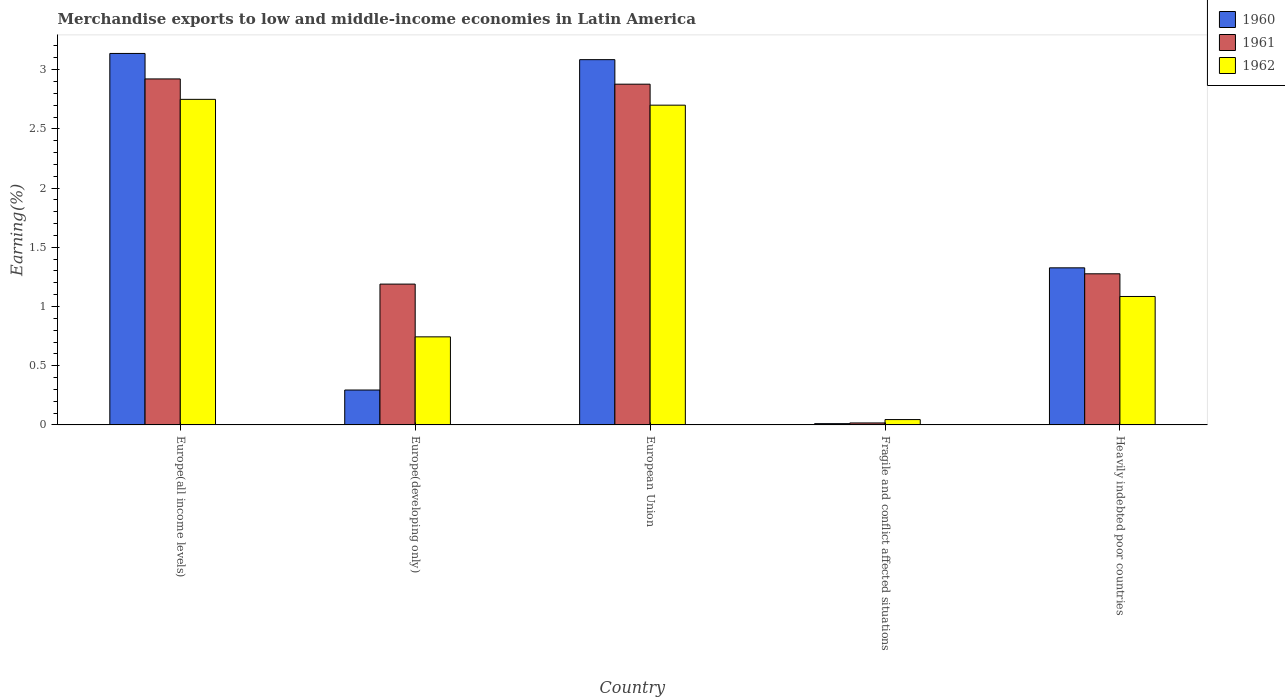How many different coloured bars are there?
Your answer should be compact. 3. What is the label of the 2nd group of bars from the left?
Provide a short and direct response. Europe(developing only). In how many cases, is the number of bars for a given country not equal to the number of legend labels?
Your answer should be very brief. 0. What is the percentage of amount earned from merchandise exports in 1961 in Europe(developing only)?
Keep it short and to the point. 1.19. Across all countries, what is the maximum percentage of amount earned from merchandise exports in 1961?
Ensure brevity in your answer.  2.92. Across all countries, what is the minimum percentage of amount earned from merchandise exports in 1961?
Provide a short and direct response. 0.02. In which country was the percentage of amount earned from merchandise exports in 1960 maximum?
Offer a terse response. Europe(all income levels). In which country was the percentage of amount earned from merchandise exports in 1962 minimum?
Offer a terse response. Fragile and conflict affected situations. What is the total percentage of amount earned from merchandise exports in 1960 in the graph?
Offer a terse response. 7.85. What is the difference between the percentage of amount earned from merchandise exports in 1960 in Europe(developing only) and that in Fragile and conflict affected situations?
Keep it short and to the point. 0.28. What is the difference between the percentage of amount earned from merchandise exports in 1960 in Fragile and conflict affected situations and the percentage of amount earned from merchandise exports in 1962 in Heavily indebted poor countries?
Your answer should be very brief. -1.07. What is the average percentage of amount earned from merchandise exports in 1960 per country?
Give a very brief answer. 1.57. What is the difference between the percentage of amount earned from merchandise exports of/in 1961 and percentage of amount earned from merchandise exports of/in 1960 in Heavily indebted poor countries?
Provide a succinct answer. -0.05. What is the ratio of the percentage of amount earned from merchandise exports in 1961 in Europe(developing only) to that in European Union?
Keep it short and to the point. 0.41. Is the difference between the percentage of amount earned from merchandise exports in 1961 in European Union and Fragile and conflict affected situations greater than the difference between the percentage of amount earned from merchandise exports in 1960 in European Union and Fragile and conflict affected situations?
Offer a terse response. No. What is the difference between the highest and the second highest percentage of amount earned from merchandise exports in 1960?
Provide a short and direct response. 1.76. What is the difference between the highest and the lowest percentage of amount earned from merchandise exports in 1961?
Your answer should be very brief. 2.91. In how many countries, is the percentage of amount earned from merchandise exports in 1962 greater than the average percentage of amount earned from merchandise exports in 1962 taken over all countries?
Ensure brevity in your answer.  2. Is it the case that in every country, the sum of the percentage of amount earned from merchandise exports in 1961 and percentage of amount earned from merchandise exports in 1962 is greater than the percentage of amount earned from merchandise exports in 1960?
Your response must be concise. Yes. Are all the bars in the graph horizontal?
Provide a short and direct response. No. How many countries are there in the graph?
Offer a terse response. 5. Does the graph contain any zero values?
Your answer should be very brief. No. Does the graph contain grids?
Provide a succinct answer. No. How many legend labels are there?
Provide a short and direct response. 3. How are the legend labels stacked?
Provide a short and direct response. Vertical. What is the title of the graph?
Provide a short and direct response. Merchandise exports to low and middle-income economies in Latin America. What is the label or title of the Y-axis?
Make the answer very short. Earning(%). What is the Earning(%) of 1960 in Europe(all income levels)?
Provide a short and direct response. 3.14. What is the Earning(%) of 1961 in Europe(all income levels)?
Offer a terse response. 2.92. What is the Earning(%) in 1962 in Europe(all income levels)?
Your answer should be compact. 2.75. What is the Earning(%) in 1960 in Europe(developing only)?
Provide a succinct answer. 0.29. What is the Earning(%) of 1961 in Europe(developing only)?
Offer a terse response. 1.19. What is the Earning(%) of 1962 in Europe(developing only)?
Your answer should be compact. 0.74. What is the Earning(%) of 1960 in European Union?
Keep it short and to the point. 3.08. What is the Earning(%) in 1961 in European Union?
Make the answer very short. 2.88. What is the Earning(%) in 1962 in European Union?
Give a very brief answer. 2.7. What is the Earning(%) of 1960 in Fragile and conflict affected situations?
Offer a terse response. 0.01. What is the Earning(%) in 1961 in Fragile and conflict affected situations?
Your answer should be very brief. 0.02. What is the Earning(%) in 1962 in Fragile and conflict affected situations?
Offer a very short reply. 0.05. What is the Earning(%) of 1960 in Heavily indebted poor countries?
Offer a very short reply. 1.33. What is the Earning(%) in 1961 in Heavily indebted poor countries?
Give a very brief answer. 1.28. What is the Earning(%) of 1962 in Heavily indebted poor countries?
Offer a terse response. 1.08. Across all countries, what is the maximum Earning(%) of 1960?
Your answer should be compact. 3.14. Across all countries, what is the maximum Earning(%) of 1961?
Offer a very short reply. 2.92. Across all countries, what is the maximum Earning(%) in 1962?
Ensure brevity in your answer.  2.75. Across all countries, what is the minimum Earning(%) in 1960?
Your answer should be very brief. 0.01. Across all countries, what is the minimum Earning(%) in 1961?
Ensure brevity in your answer.  0.02. Across all countries, what is the minimum Earning(%) of 1962?
Make the answer very short. 0.05. What is the total Earning(%) of 1960 in the graph?
Your answer should be compact. 7.85. What is the total Earning(%) of 1961 in the graph?
Provide a short and direct response. 8.28. What is the total Earning(%) of 1962 in the graph?
Give a very brief answer. 7.32. What is the difference between the Earning(%) of 1960 in Europe(all income levels) and that in Europe(developing only)?
Your response must be concise. 2.84. What is the difference between the Earning(%) in 1961 in Europe(all income levels) and that in Europe(developing only)?
Offer a very short reply. 1.73. What is the difference between the Earning(%) in 1962 in Europe(all income levels) and that in Europe(developing only)?
Provide a short and direct response. 2.01. What is the difference between the Earning(%) in 1960 in Europe(all income levels) and that in European Union?
Your answer should be compact. 0.05. What is the difference between the Earning(%) in 1961 in Europe(all income levels) and that in European Union?
Offer a very short reply. 0.04. What is the difference between the Earning(%) of 1962 in Europe(all income levels) and that in European Union?
Provide a succinct answer. 0.05. What is the difference between the Earning(%) in 1960 in Europe(all income levels) and that in Fragile and conflict affected situations?
Ensure brevity in your answer.  3.13. What is the difference between the Earning(%) of 1961 in Europe(all income levels) and that in Fragile and conflict affected situations?
Ensure brevity in your answer.  2.91. What is the difference between the Earning(%) of 1962 in Europe(all income levels) and that in Fragile and conflict affected situations?
Make the answer very short. 2.7. What is the difference between the Earning(%) of 1960 in Europe(all income levels) and that in Heavily indebted poor countries?
Ensure brevity in your answer.  1.81. What is the difference between the Earning(%) of 1961 in Europe(all income levels) and that in Heavily indebted poor countries?
Provide a short and direct response. 1.65. What is the difference between the Earning(%) of 1962 in Europe(all income levels) and that in Heavily indebted poor countries?
Provide a succinct answer. 1.66. What is the difference between the Earning(%) of 1960 in Europe(developing only) and that in European Union?
Make the answer very short. -2.79. What is the difference between the Earning(%) in 1961 in Europe(developing only) and that in European Union?
Keep it short and to the point. -1.69. What is the difference between the Earning(%) in 1962 in Europe(developing only) and that in European Union?
Provide a short and direct response. -1.96. What is the difference between the Earning(%) of 1960 in Europe(developing only) and that in Fragile and conflict affected situations?
Your answer should be very brief. 0.28. What is the difference between the Earning(%) of 1961 in Europe(developing only) and that in Fragile and conflict affected situations?
Your response must be concise. 1.17. What is the difference between the Earning(%) of 1962 in Europe(developing only) and that in Fragile and conflict affected situations?
Your response must be concise. 0.7. What is the difference between the Earning(%) of 1960 in Europe(developing only) and that in Heavily indebted poor countries?
Provide a short and direct response. -1.03. What is the difference between the Earning(%) of 1961 in Europe(developing only) and that in Heavily indebted poor countries?
Provide a succinct answer. -0.09. What is the difference between the Earning(%) of 1962 in Europe(developing only) and that in Heavily indebted poor countries?
Provide a short and direct response. -0.34. What is the difference between the Earning(%) of 1960 in European Union and that in Fragile and conflict affected situations?
Your answer should be compact. 3.07. What is the difference between the Earning(%) of 1961 in European Union and that in Fragile and conflict affected situations?
Your answer should be very brief. 2.86. What is the difference between the Earning(%) in 1962 in European Union and that in Fragile and conflict affected situations?
Offer a very short reply. 2.65. What is the difference between the Earning(%) of 1960 in European Union and that in Heavily indebted poor countries?
Your answer should be compact. 1.76. What is the difference between the Earning(%) of 1961 in European Union and that in Heavily indebted poor countries?
Your response must be concise. 1.6. What is the difference between the Earning(%) in 1962 in European Union and that in Heavily indebted poor countries?
Provide a succinct answer. 1.62. What is the difference between the Earning(%) in 1960 in Fragile and conflict affected situations and that in Heavily indebted poor countries?
Your answer should be very brief. -1.32. What is the difference between the Earning(%) in 1961 in Fragile and conflict affected situations and that in Heavily indebted poor countries?
Offer a terse response. -1.26. What is the difference between the Earning(%) of 1962 in Fragile and conflict affected situations and that in Heavily indebted poor countries?
Your answer should be very brief. -1.04. What is the difference between the Earning(%) in 1960 in Europe(all income levels) and the Earning(%) in 1961 in Europe(developing only)?
Make the answer very short. 1.95. What is the difference between the Earning(%) of 1960 in Europe(all income levels) and the Earning(%) of 1962 in Europe(developing only)?
Offer a terse response. 2.39. What is the difference between the Earning(%) of 1961 in Europe(all income levels) and the Earning(%) of 1962 in Europe(developing only)?
Keep it short and to the point. 2.18. What is the difference between the Earning(%) of 1960 in Europe(all income levels) and the Earning(%) of 1961 in European Union?
Provide a succinct answer. 0.26. What is the difference between the Earning(%) of 1960 in Europe(all income levels) and the Earning(%) of 1962 in European Union?
Provide a short and direct response. 0.44. What is the difference between the Earning(%) in 1961 in Europe(all income levels) and the Earning(%) in 1962 in European Union?
Provide a short and direct response. 0.22. What is the difference between the Earning(%) of 1960 in Europe(all income levels) and the Earning(%) of 1961 in Fragile and conflict affected situations?
Your response must be concise. 3.12. What is the difference between the Earning(%) of 1960 in Europe(all income levels) and the Earning(%) of 1962 in Fragile and conflict affected situations?
Provide a succinct answer. 3.09. What is the difference between the Earning(%) in 1961 in Europe(all income levels) and the Earning(%) in 1962 in Fragile and conflict affected situations?
Your answer should be very brief. 2.88. What is the difference between the Earning(%) in 1960 in Europe(all income levels) and the Earning(%) in 1961 in Heavily indebted poor countries?
Make the answer very short. 1.86. What is the difference between the Earning(%) in 1960 in Europe(all income levels) and the Earning(%) in 1962 in Heavily indebted poor countries?
Keep it short and to the point. 2.05. What is the difference between the Earning(%) in 1961 in Europe(all income levels) and the Earning(%) in 1962 in Heavily indebted poor countries?
Give a very brief answer. 1.84. What is the difference between the Earning(%) of 1960 in Europe(developing only) and the Earning(%) of 1961 in European Union?
Give a very brief answer. -2.58. What is the difference between the Earning(%) in 1960 in Europe(developing only) and the Earning(%) in 1962 in European Union?
Make the answer very short. -2.41. What is the difference between the Earning(%) in 1961 in Europe(developing only) and the Earning(%) in 1962 in European Union?
Your response must be concise. -1.51. What is the difference between the Earning(%) of 1960 in Europe(developing only) and the Earning(%) of 1961 in Fragile and conflict affected situations?
Your response must be concise. 0.28. What is the difference between the Earning(%) of 1960 in Europe(developing only) and the Earning(%) of 1962 in Fragile and conflict affected situations?
Give a very brief answer. 0.25. What is the difference between the Earning(%) in 1961 in Europe(developing only) and the Earning(%) in 1962 in Fragile and conflict affected situations?
Offer a terse response. 1.14. What is the difference between the Earning(%) in 1960 in Europe(developing only) and the Earning(%) in 1961 in Heavily indebted poor countries?
Your response must be concise. -0.98. What is the difference between the Earning(%) in 1960 in Europe(developing only) and the Earning(%) in 1962 in Heavily indebted poor countries?
Keep it short and to the point. -0.79. What is the difference between the Earning(%) in 1961 in Europe(developing only) and the Earning(%) in 1962 in Heavily indebted poor countries?
Keep it short and to the point. 0.1. What is the difference between the Earning(%) in 1960 in European Union and the Earning(%) in 1961 in Fragile and conflict affected situations?
Offer a very short reply. 3.07. What is the difference between the Earning(%) of 1960 in European Union and the Earning(%) of 1962 in Fragile and conflict affected situations?
Provide a short and direct response. 3.04. What is the difference between the Earning(%) of 1961 in European Union and the Earning(%) of 1962 in Fragile and conflict affected situations?
Ensure brevity in your answer.  2.83. What is the difference between the Earning(%) of 1960 in European Union and the Earning(%) of 1961 in Heavily indebted poor countries?
Your response must be concise. 1.81. What is the difference between the Earning(%) of 1960 in European Union and the Earning(%) of 1962 in Heavily indebted poor countries?
Ensure brevity in your answer.  2. What is the difference between the Earning(%) of 1961 in European Union and the Earning(%) of 1962 in Heavily indebted poor countries?
Your response must be concise. 1.79. What is the difference between the Earning(%) of 1960 in Fragile and conflict affected situations and the Earning(%) of 1961 in Heavily indebted poor countries?
Your answer should be compact. -1.27. What is the difference between the Earning(%) of 1960 in Fragile and conflict affected situations and the Earning(%) of 1962 in Heavily indebted poor countries?
Offer a terse response. -1.07. What is the difference between the Earning(%) of 1961 in Fragile and conflict affected situations and the Earning(%) of 1962 in Heavily indebted poor countries?
Ensure brevity in your answer.  -1.07. What is the average Earning(%) of 1960 per country?
Keep it short and to the point. 1.57. What is the average Earning(%) of 1961 per country?
Your response must be concise. 1.66. What is the average Earning(%) of 1962 per country?
Your answer should be very brief. 1.46. What is the difference between the Earning(%) of 1960 and Earning(%) of 1961 in Europe(all income levels)?
Your answer should be compact. 0.22. What is the difference between the Earning(%) in 1960 and Earning(%) in 1962 in Europe(all income levels)?
Make the answer very short. 0.39. What is the difference between the Earning(%) of 1961 and Earning(%) of 1962 in Europe(all income levels)?
Provide a succinct answer. 0.17. What is the difference between the Earning(%) in 1960 and Earning(%) in 1961 in Europe(developing only)?
Keep it short and to the point. -0.89. What is the difference between the Earning(%) in 1960 and Earning(%) in 1962 in Europe(developing only)?
Offer a terse response. -0.45. What is the difference between the Earning(%) in 1961 and Earning(%) in 1962 in Europe(developing only)?
Keep it short and to the point. 0.45. What is the difference between the Earning(%) in 1960 and Earning(%) in 1961 in European Union?
Provide a short and direct response. 0.21. What is the difference between the Earning(%) in 1960 and Earning(%) in 1962 in European Union?
Offer a terse response. 0.38. What is the difference between the Earning(%) in 1961 and Earning(%) in 1962 in European Union?
Make the answer very short. 0.18. What is the difference between the Earning(%) of 1960 and Earning(%) of 1961 in Fragile and conflict affected situations?
Offer a terse response. -0.01. What is the difference between the Earning(%) of 1960 and Earning(%) of 1962 in Fragile and conflict affected situations?
Offer a very short reply. -0.03. What is the difference between the Earning(%) in 1961 and Earning(%) in 1962 in Fragile and conflict affected situations?
Offer a terse response. -0.03. What is the difference between the Earning(%) in 1960 and Earning(%) in 1961 in Heavily indebted poor countries?
Make the answer very short. 0.05. What is the difference between the Earning(%) in 1960 and Earning(%) in 1962 in Heavily indebted poor countries?
Make the answer very short. 0.24. What is the difference between the Earning(%) in 1961 and Earning(%) in 1962 in Heavily indebted poor countries?
Make the answer very short. 0.19. What is the ratio of the Earning(%) in 1960 in Europe(all income levels) to that in Europe(developing only)?
Make the answer very short. 10.65. What is the ratio of the Earning(%) of 1961 in Europe(all income levels) to that in Europe(developing only)?
Give a very brief answer. 2.46. What is the ratio of the Earning(%) in 1962 in Europe(all income levels) to that in Europe(developing only)?
Your response must be concise. 3.7. What is the ratio of the Earning(%) in 1961 in Europe(all income levels) to that in European Union?
Provide a succinct answer. 1.02. What is the ratio of the Earning(%) in 1962 in Europe(all income levels) to that in European Union?
Provide a short and direct response. 1.02. What is the ratio of the Earning(%) in 1960 in Europe(all income levels) to that in Fragile and conflict affected situations?
Make the answer very short. 294.71. What is the ratio of the Earning(%) in 1961 in Europe(all income levels) to that in Fragile and conflict affected situations?
Provide a short and direct response. 175.56. What is the ratio of the Earning(%) of 1962 in Europe(all income levels) to that in Fragile and conflict affected situations?
Give a very brief answer. 60.9. What is the ratio of the Earning(%) in 1960 in Europe(all income levels) to that in Heavily indebted poor countries?
Your response must be concise. 2.36. What is the ratio of the Earning(%) in 1961 in Europe(all income levels) to that in Heavily indebted poor countries?
Provide a short and direct response. 2.29. What is the ratio of the Earning(%) in 1962 in Europe(all income levels) to that in Heavily indebted poor countries?
Keep it short and to the point. 2.53. What is the ratio of the Earning(%) of 1960 in Europe(developing only) to that in European Union?
Make the answer very short. 0.1. What is the ratio of the Earning(%) of 1961 in Europe(developing only) to that in European Union?
Provide a succinct answer. 0.41. What is the ratio of the Earning(%) of 1962 in Europe(developing only) to that in European Union?
Ensure brevity in your answer.  0.28. What is the ratio of the Earning(%) in 1960 in Europe(developing only) to that in Fragile and conflict affected situations?
Ensure brevity in your answer.  27.68. What is the ratio of the Earning(%) in 1961 in Europe(developing only) to that in Fragile and conflict affected situations?
Your answer should be very brief. 71.45. What is the ratio of the Earning(%) of 1962 in Europe(developing only) to that in Fragile and conflict affected situations?
Keep it short and to the point. 16.47. What is the ratio of the Earning(%) in 1960 in Europe(developing only) to that in Heavily indebted poor countries?
Give a very brief answer. 0.22. What is the ratio of the Earning(%) of 1961 in Europe(developing only) to that in Heavily indebted poor countries?
Make the answer very short. 0.93. What is the ratio of the Earning(%) in 1962 in Europe(developing only) to that in Heavily indebted poor countries?
Keep it short and to the point. 0.69. What is the ratio of the Earning(%) of 1960 in European Union to that in Fragile and conflict affected situations?
Your answer should be very brief. 289.8. What is the ratio of the Earning(%) of 1961 in European Union to that in Fragile and conflict affected situations?
Your answer should be very brief. 172.89. What is the ratio of the Earning(%) in 1962 in European Union to that in Fragile and conflict affected situations?
Keep it short and to the point. 59.81. What is the ratio of the Earning(%) in 1960 in European Union to that in Heavily indebted poor countries?
Make the answer very short. 2.33. What is the ratio of the Earning(%) in 1961 in European Union to that in Heavily indebted poor countries?
Your answer should be very brief. 2.25. What is the ratio of the Earning(%) in 1962 in European Union to that in Heavily indebted poor countries?
Provide a short and direct response. 2.49. What is the ratio of the Earning(%) in 1960 in Fragile and conflict affected situations to that in Heavily indebted poor countries?
Your answer should be compact. 0.01. What is the ratio of the Earning(%) in 1961 in Fragile and conflict affected situations to that in Heavily indebted poor countries?
Offer a very short reply. 0.01. What is the ratio of the Earning(%) in 1962 in Fragile and conflict affected situations to that in Heavily indebted poor countries?
Your answer should be compact. 0.04. What is the difference between the highest and the second highest Earning(%) in 1960?
Your answer should be compact. 0.05. What is the difference between the highest and the second highest Earning(%) in 1961?
Keep it short and to the point. 0.04. What is the difference between the highest and the second highest Earning(%) in 1962?
Offer a very short reply. 0.05. What is the difference between the highest and the lowest Earning(%) of 1960?
Offer a very short reply. 3.13. What is the difference between the highest and the lowest Earning(%) of 1961?
Keep it short and to the point. 2.91. What is the difference between the highest and the lowest Earning(%) in 1962?
Provide a short and direct response. 2.7. 